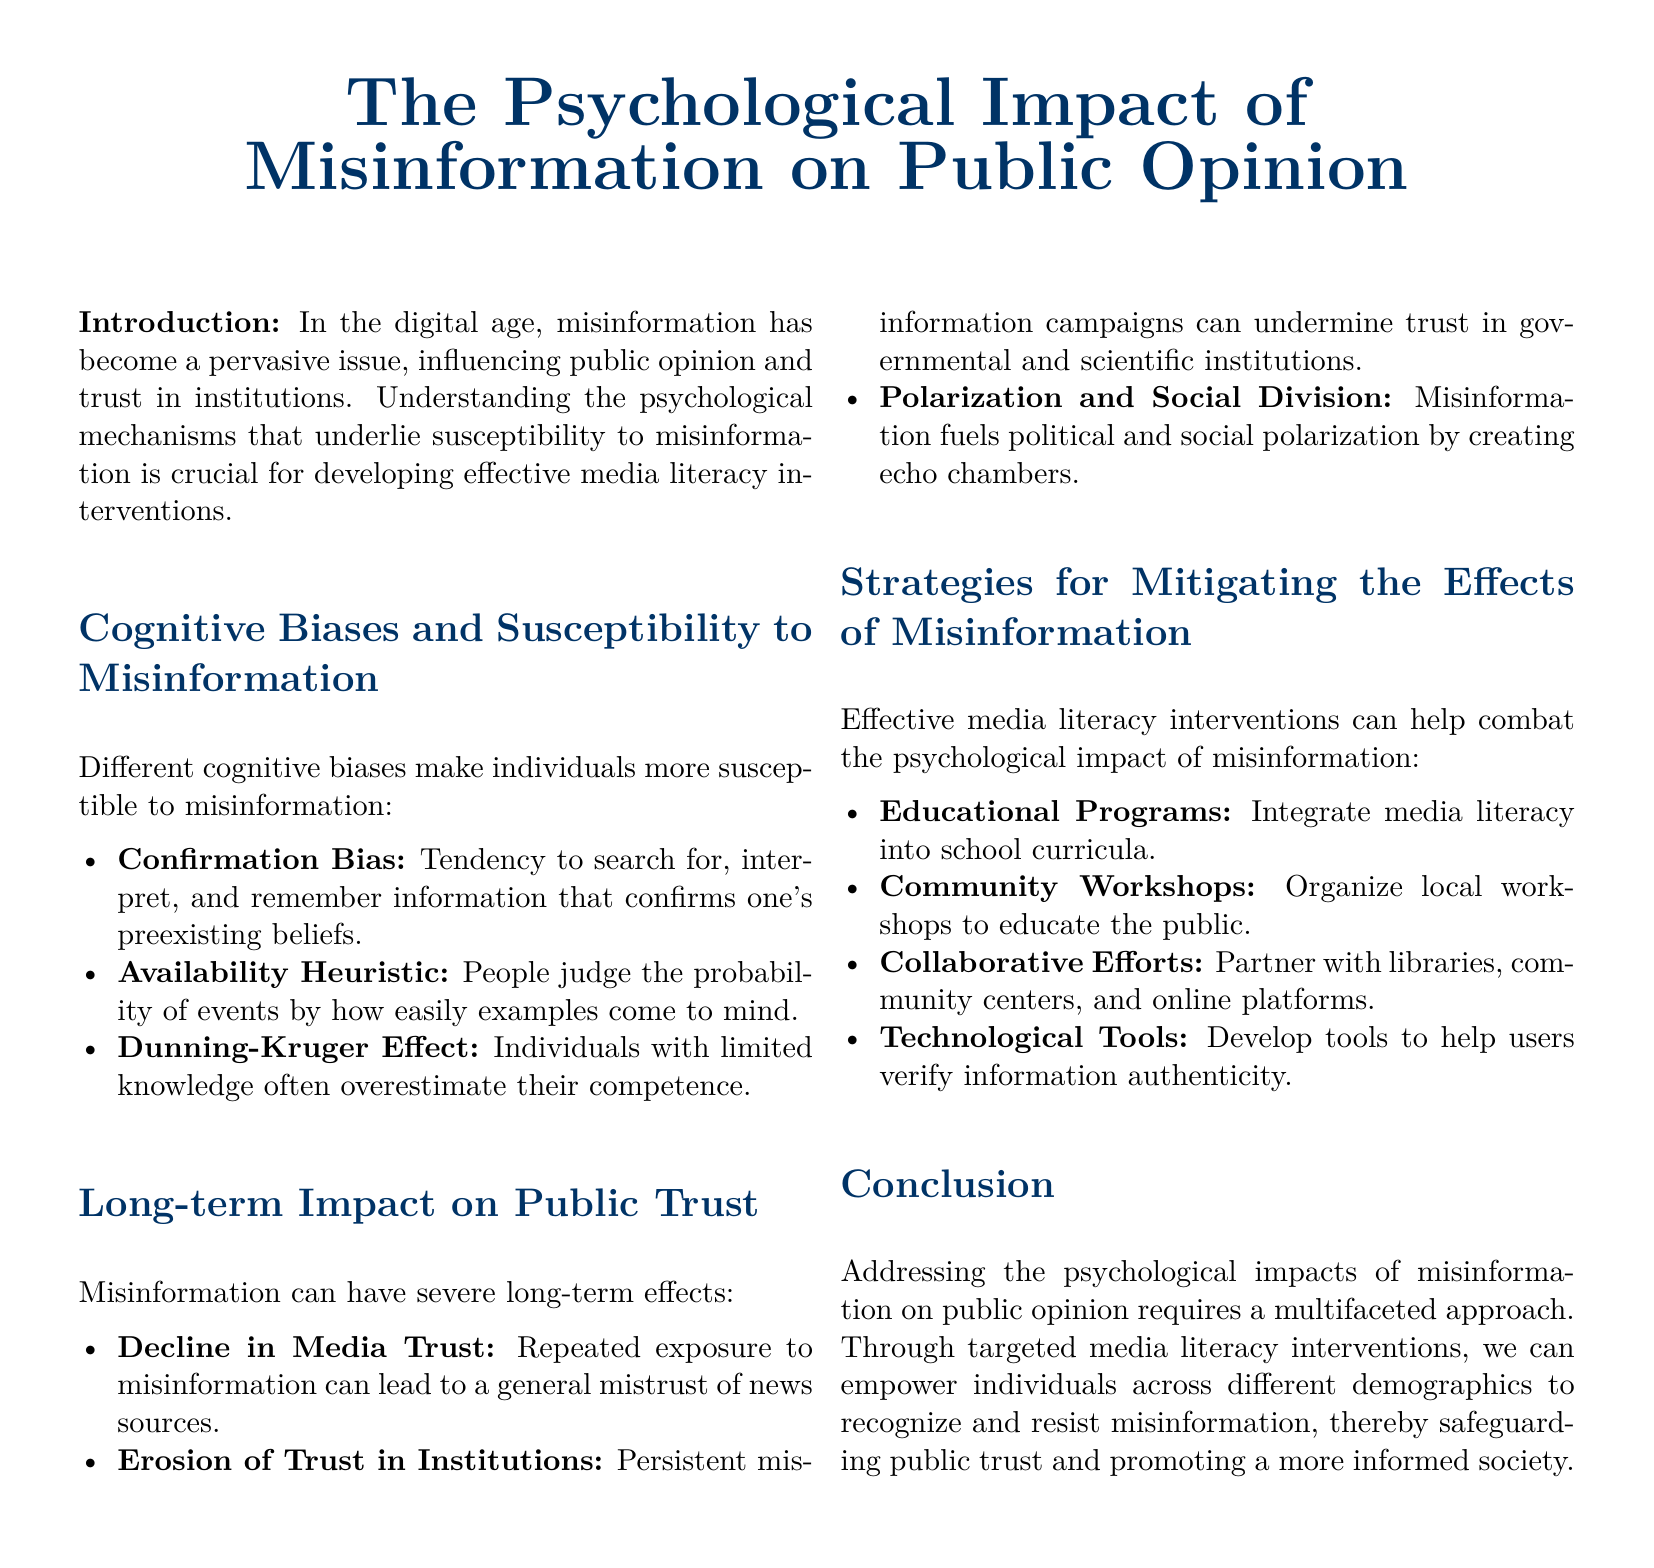What is the title of the whitepaper? The title is presented in a prominent position at the top of the document.
Answer: The Psychological Impact of Misinformation on Public Opinion What cognitive bias refers to the tendency to search for information that confirms one's preexisting beliefs? This cognitive bias is specifically mentioned in the section on cognitive biases and susceptibility to misinformation.
Answer: Confirmation Bias Name one long-term impact of misinformation on public trust. The document lists specific impacts on public trust in the section discussing long-term effects.
Answer: Decline in Media Trust What is one strategy for mitigating the effects of misinformation mentioned in the whitepaper? The document provides examples of strategies in a specific section addressing mitigation efforts.
Answer: Educational Programs Which cognitive bias involves individuals with limited knowledge overestimating their competence? This concept is explained within the cognitive biases section of the document.
Answer: Dunning-Kruger Effect List one collaborative effort mentioned for combating misinformation. The document suggests different collaborative efforts to address misinformation in its strategies section.
Answer: Partner with libraries What psychological effect does misinformation fuel according to the whitepaper? The document discusses this effect in relation to public opinion and social dynamics.
Answer: Polarization and Social Division How many cognitive biases are discussed in the whitepaper? The number of biases can be counted in the section on cognitive biases.
Answer: Three What type of workshops does the document suggest organizing? The document specifies the type of workshops aimed at public education in its strategies for mitigation.
Answer: Community Workshops 